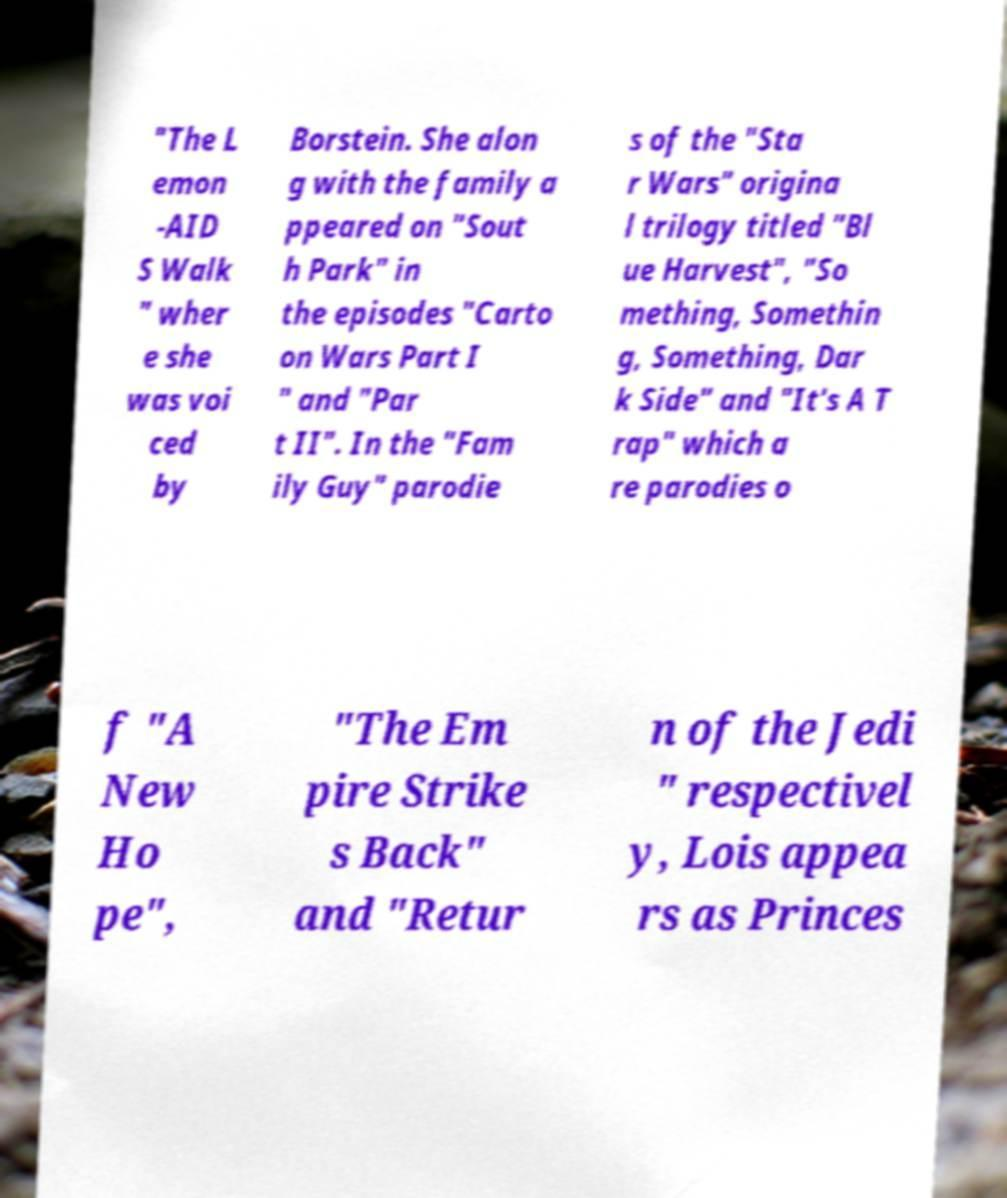I need the written content from this picture converted into text. Can you do that? "The L emon -AID S Walk " wher e she was voi ced by Borstein. She alon g with the family a ppeared on "Sout h Park" in the episodes "Carto on Wars Part I " and "Par t II". In the "Fam ily Guy" parodie s of the "Sta r Wars" origina l trilogy titled "Bl ue Harvest", "So mething, Somethin g, Something, Dar k Side" and "It's A T rap" which a re parodies o f "A New Ho pe", "The Em pire Strike s Back" and "Retur n of the Jedi " respectivel y, Lois appea rs as Princes 